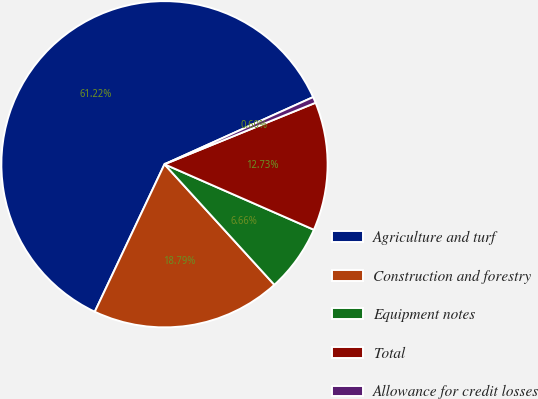<chart> <loc_0><loc_0><loc_500><loc_500><pie_chart><fcel>Agriculture and turf<fcel>Construction and forestry<fcel>Equipment notes<fcel>Total<fcel>Allowance for credit losses<nl><fcel>61.22%<fcel>18.79%<fcel>6.66%<fcel>12.73%<fcel>0.6%<nl></chart> 